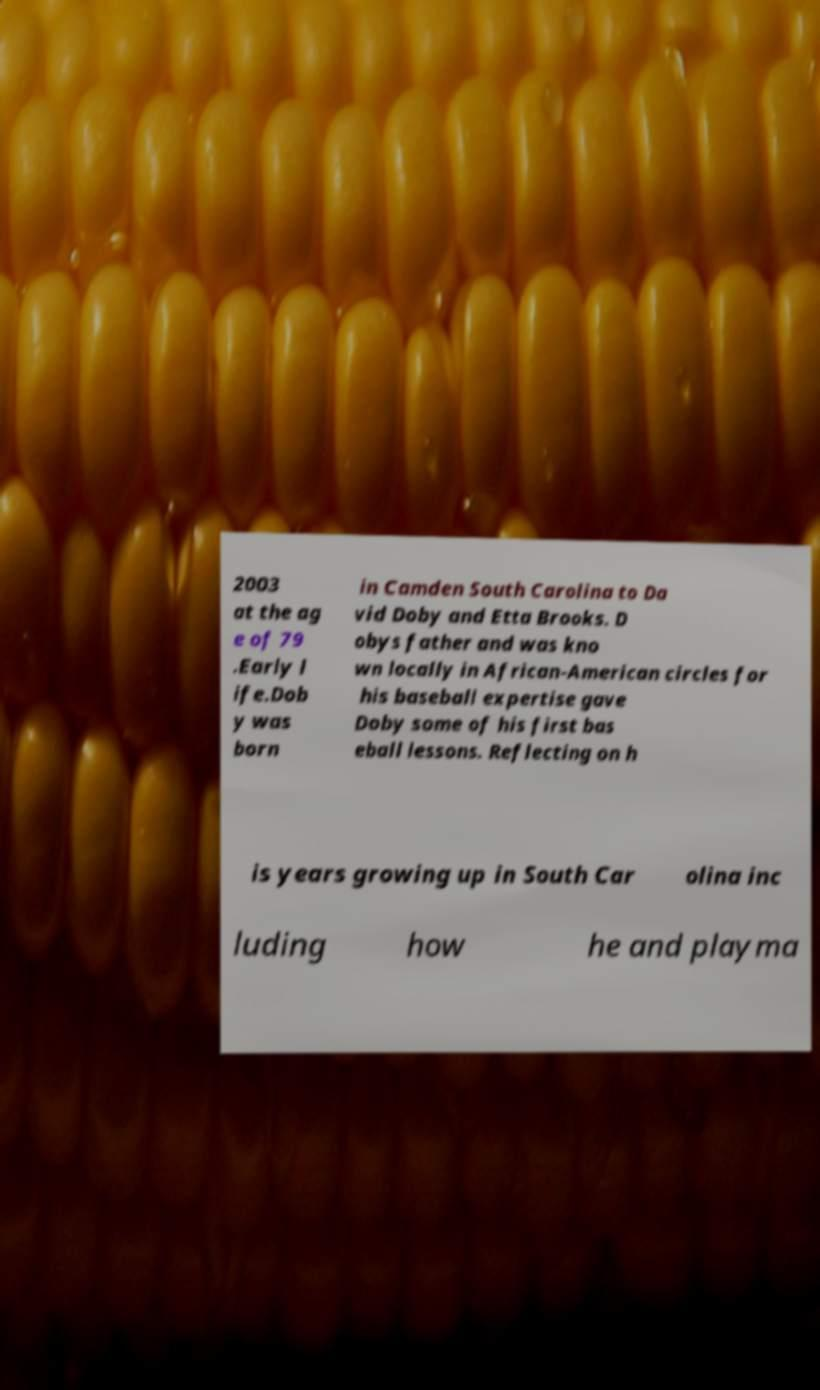Can you read and provide the text displayed in the image?This photo seems to have some interesting text. Can you extract and type it out for me? 2003 at the ag e of 79 .Early l ife.Dob y was born in Camden South Carolina to Da vid Doby and Etta Brooks. D obys father and was kno wn locally in African-American circles for his baseball expertise gave Doby some of his first bas eball lessons. Reflecting on h is years growing up in South Car olina inc luding how he and playma 